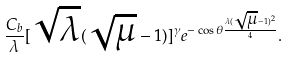Convert formula to latex. <formula><loc_0><loc_0><loc_500><loc_500>\frac { C _ { b } } { \lambda } [ \sqrt { \lambda } ( \sqrt { \mu } - 1 ) ] ^ { \gamma } e ^ { - \cos \theta \frac { \lambda ( \sqrt { \mu } - 1 ) ^ { 2 } } { 4 } } .</formula> 